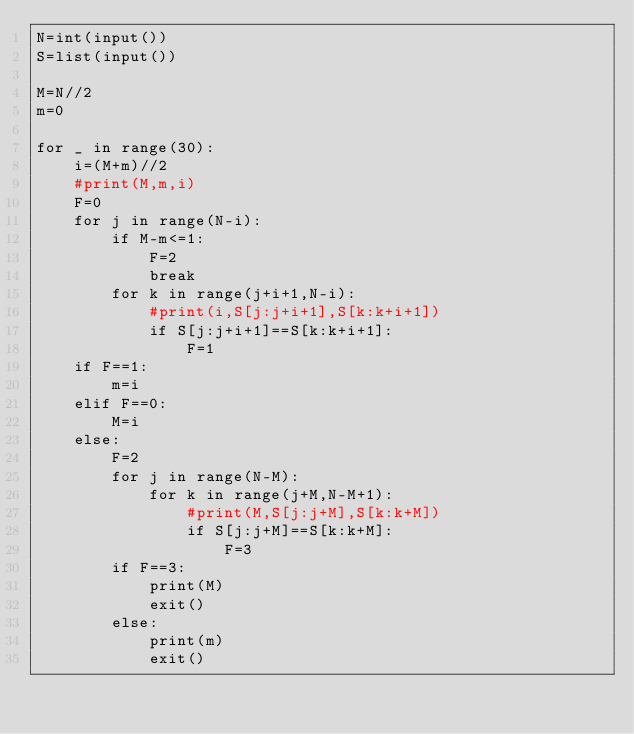Convert code to text. <code><loc_0><loc_0><loc_500><loc_500><_Python_>N=int(input())
S=list(input())

M=N//2
m=0

for _ in range(30):
    i=(M+m)//2
    #print(M,m,i)
    F=0
    for j in range(N-i):
        if M-m<=1:
            F=2
            break
        for k in range(j+i+1,N-i):
            #print(i,S[j:j+i+1],S[k:k+i+1])
            if S[j:j+i+1]==S[k:k+i+1]:
                F=1
    if F==1:
        m=i
    elif F==0:
        M=i
    else:
        F=2
        for j in range(N-M):
            for k in range(j+M,N-M+1):
                #print(M,S[j:j+M],S[k:k+M])
                if S[j:j+M]==S[k:k+M]:
                    F=3
        if F==3:
            print(M)
            exit()
        else:
            print(m)
            exit()  </code> 